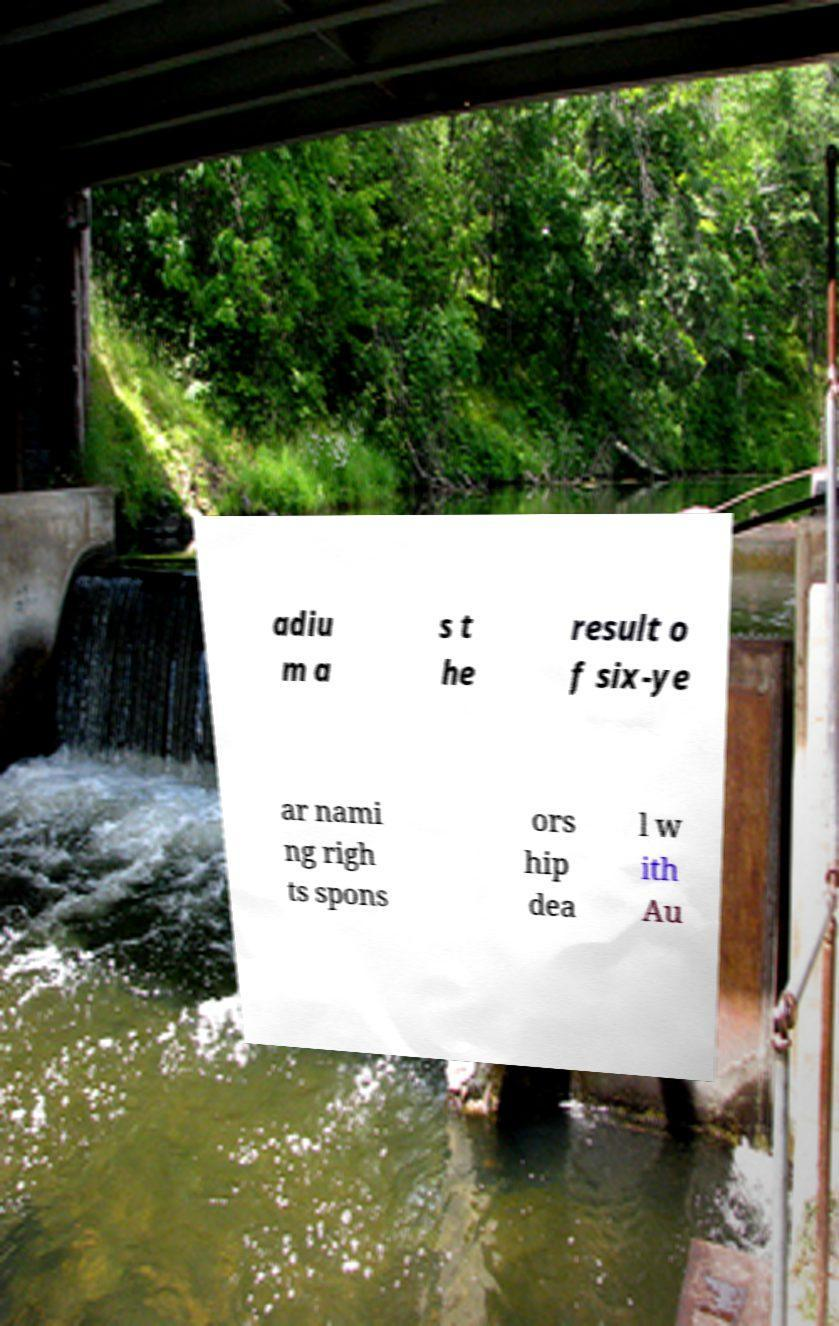I need the written content from this picture converted into text. Can you do that? adiu m a s t he result o f six-ye ar nami ng righ ts spons ors hip dea l w ith Au 